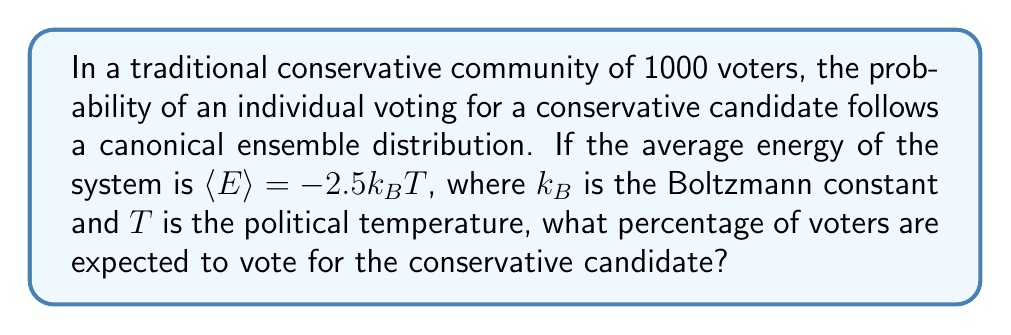Could you help me with this problem? To solve this problem, we'll use the principles of statistical mechanics and the canonical ensemble:

1) In the canonical ensemble, the probability of a state with energy $E$ is given by:

   $$P(E) = \frac{1}{Z} e^{-\beta E}$$

   where $\beta = \frac{1}{k_BT}$ and $Z$ is the partition function.

2) For a two-state system (vote conservative or not), we can assign energy levels:
   $E_1 = -E$ (conservative vote)
   $E_2 = +E$ (non-conservative vote)

3) The partition function Z is:

   $$Z = e^{-\beta(-E)} + e^{-\beta(+E)} = e^{\beta E} + e^{-\beta E}$$

4) The average energy is given by:

   $$\langle E \rangle = -\frac{\partial \ln Z}{\partial \beta} = -2.5k_BT$$

5) Solving this equation:

   $$-2.5k_BT = -E\frac{e^{\beta E} - e^{-\beta E}}{e^{\beta E} + e^{-\beta E}}$$

6) This simplifies to:

   $$\frac{e^{\beta E} - e^{-\beta E}}{e^{\beta E} + e^{-\beta E}} = 2.5$$

7) Solving for $\beta E$:

   $$\beta E = \ln(7) \approx 1.946$$

8) The probability of voting conservative is:

   $$P_1 = \frac{e^{\beta E}}{e^{\beta E} + e^{-\beta E}} = \frac{e^{1.946}}{e^{1.946} + e^{-1.946}} \approx 0.875$$

9) Converting to a percentage:

   $0.875 * 100\% = 87.5\%$
Answer: 87.5% 